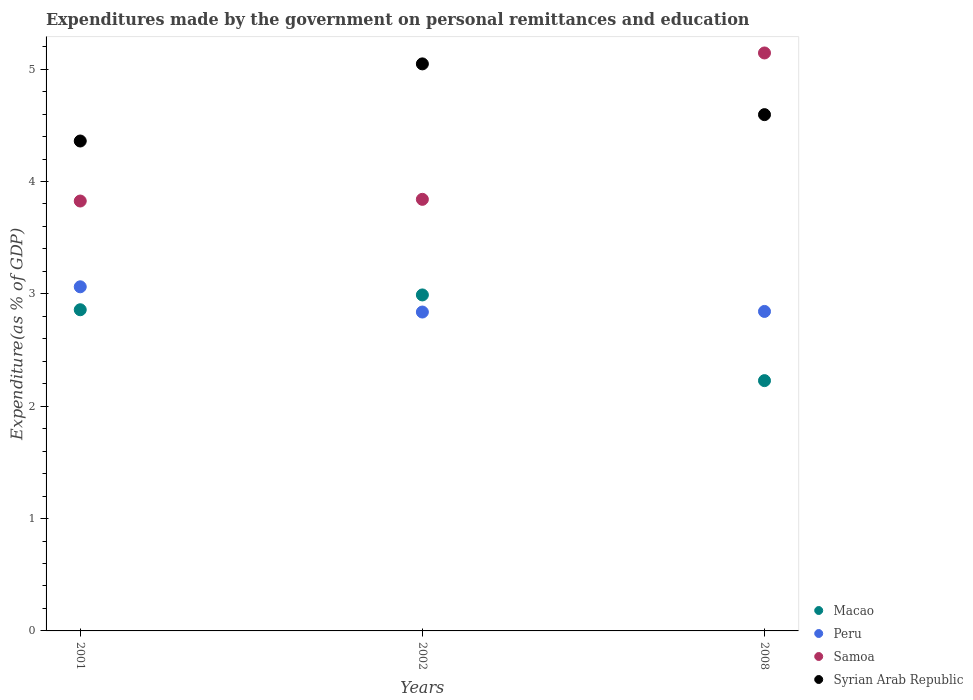What is the expenditures made by the government on personal remittances and education in Peru in 2008?
Your response must be concise. 2.84. Across all years, what is the maximum expenditures made by the government on personal remittances and education in Syrian Arab Republic?
Provide a succinct answer. 5.05. Across all years, what is the minimum expenditures made by the government on personal remittances and education in Samoa?
Provide a short and direct response. 3.83. What is the total expenditures made by the government on personal remittances and education in Samoa in the graph?
Provide a short and direct response. 12.81. What is the difference between the expenditures made by the government on personal remittances and education in Syrian Arab Republic in 2001 and that in 2008?
Ensure brevity in your answer.  -0.23. What is the difference between the expenditures made by the government on personal remittances and education in Samoa in 2001 and the expenditures made by the government on personal remittances and education in Macao in 2008?
Ensure brevity in your answer.  1.6. What is the average expenditures made by the government on personal remittances and education in Macao per year?
Offer a very short reply. 2.69. In the year 2001, what is the difference between the expenditures made by the government on personal remittances and education in Samoa and expenditures made by the government on personal remittances and education in Peru?
Offer a terse response. 0.76. In how many years, is the expenditures made by the government on personal remittances and education in Syrian Arab Republic greater than 0.4 %?
Keep it short and to the point. 3. What is the ratio of the expenditures made by the government on personal remittances and education in Samoa in 2001 to that in 2008?
Your answer should be compact. 0.74. Is the expenditures made by the government on personal remittances and education in Macao in 2001 less than that in 2008?
Your response must be concise. No. Is the difference between the expenditures made by the government on personal remittances and education in Samoa in 2001 and 2008 greater than the difference between the expenditures made by the government on personal remittances and education in Peru in 2001 and 2008?
Provide a succinct answer. No. What is the difference between the highest and the second highest expenditures made by the government on personal remittances and education in Macao?
Your answer should be compact. 0.13. What is the difference between the highest and the lowest expenditures made by the government on personal remittances and education in Syrian Arab Republic?
Your answer should be compact. 0.69. In how many years, is the expenditures made by the government on personal remittances and education in Samoa greater than the average expenditures made by the government on personal remittances and education in Samoa taken over all years?
Provide a short and direct response. 1. Is the sum of the expenditures made by the government on personal remittances and education in Syrian Arab Republic in 2002 and 2008 greater than the maximum expenditures made by the government on personal remittances and education in Peru across all years?
Provide a succinct answer. Yes. Is it the case that in every year, the sum of the expenditures made by the government on personal remittances and education in Samoa and expenditures made by the government on personal remittances and education in Syrian Arab Republic  is greater than the sum of expenditures made by the government on personal remittances and education in Peru and expenditures made by the government on personal remittances and education in Macao?
Offer a very short reply. Yes. Is the expenditures made by the government on personal remittances and education in Macao strictly greater than the expenditures made by the government on personal remittances and education in Samoa over the years?
Your answer should be compact. No. Is the expenditures made by the government on personal remittances and education in Samoa strictly less than the expenditures made by the government on personal remittances and education in Syrian Arab Republic over the years?
Ensure brevity in your answer.  No. What is the difference between two consecutive major ticks on the Y-axis?
Give a very brief answer. 1. Are the values on the major ticks of Y-axis written in scientific E-notation?
Your answer should be very brief. No. Does the graph contain any zero values?
Ensure brevity in your answer.  No. How many legend labels are there?
Give a very brief answer. 4. What is the title of the graph?
Your answer should be very brief. Expenditures made by the government on personal remittances and education. What is the label or title of the X-axis?
Offer a terse response. Years. What is the label or title of the Y-axis?
Ensure brevity in your answer.  Expenditure(as % of GDP). What is the Expenditure(as % of GDP) in Macao in 2001?
Provide a short and direct response. 2.86. What is the Expenditure(as % of GDP) of Peru in 2001?
Ensure brevity in your answer.  3.06. What is the Expenditure(as % of GDP) in Samoa in 2001?
Your answer should be compact. 3.83. What is the Expenditure(as % of GDP) of Syrian Arab Republic in 2001?
Your answer should be compact. 4.36. What is the Expenditure(as % of GDP) in Macao in 2002?
Your answer should be very brief. 2.99. What is the Expenditure(as % of GDP) of Peru in 2002?
Keep it short and to the point. 2.84. What is the Expenditure(as % of GDP) in Samoa in 2002?
Give a very brief answer. 3.84. What is the Expenditure(as % of GDP) in Syrian Arab Republic in 2002?
Ensure brevity in your answer.  5.05. What is the Expenditure(as % of GDP) in Macao in 2008?
Your response must be concise. 2.23. What is the Expenditure(as % of GDP) of Peru in 2008?
Your answer should be compact. 2.84. What is the Expenditure(as % of GDP) in Samoa in 2008?
Ensure brevity in your answer.  5.14. What is the Expenditure(as % of GDP) in Syrian Arab Republic in 2008?
Make the answer very short. 4.6. Across all years, what is the maximum Expenditure(as % of GDP) of Macao?
Ensure brevity in your answer.  2.99. Across all years, what is the maximum Expenditure(as % of GDP) of Peru?
Give a very brief answer. 3.06. Across all years, what is the maximum Expenditure(as % of GDP) in Samoa?
Your answer should be compact. 5.14. Across all years, what is the maximum Expenditure(as % of GDP) of Syrian Arab Republic?
Your answer should be very brief. 5.05. Across all years, what is the minimum Expenditure(as % of GDP) of Macao?
Ensure brevity in your answer.  2.23. Across all years, what is the minimum Expenditure(as % of GDP) in Peru?
Keep it short and to the point. 2.84. Across all years, what is the minimum Expenditure(as % of GDP) of Samoa?
Provide a succinct answer. 3.83. Across all years, what is the minimum Expenditure(as % of GDP) in Syrian Arab Republic?
Give a very brief answer. 4.36. What is the total Expenditure(as % of GDP) in Macao in the graph?
Provide a short and direct response. 8.08. What is the total Expenditure(as % of GDP) of Peru in the graph?
Provide a short and direct response. 8.74. What is the total Expenditure(as % of GDP) in Samoa in the graph?
Provide a succinct answer. 12.81. What is the total Expenditure(as % of GDP) of Syrian Arab Republic in the graph?
Keep it short and to the point. 14. What is the difference between the Expenditure(as % of GDP) in Macao in 2001 and that in 2002?
Make the answer very short. -0.13. What is the difference between the Expenditure(as % of GDP) of Peru in 2001 and that in 2002?
Offer a terse response. 0.22. What is the difference between the Expenditure(as % of GDP) of Samoa in 2001 and that in 2002?
Offer a terse response. -0.02. What is the difference between the Expenditure(as % of GDP) in Syrian Arab Republic in 2001 and that in 2002?
Keep it short and to the point. -0.69. What is the difference between the Expenditure(as % of GDP) of Macao in 2001 and that in 2008?
Ensure brevity in your answer.  0.63. What is the difference between the Expenditure(as % of GDP) in Peru in 2001 and that in 2008?
Your response must be concise. 0.22. What is the difference between the Expenditure(as % of GDP) of Samoa in 2001 and that in 2008?
Your response must be concise. -1.32. What is the difference between the Expenditure(as % of GDP) in Syrian Arab Republic in 2001 and that in 2008?
Offer a very short reply. -0.23. What is the difference between the Expenditure(as % of GDP) in Macao in 2002 and that in 2008?
Your answer should be very brief. 0.76. What is the difference between the Expenditure(as % of GDP) of Peru in 2002 and that in 2008?
Give a very brief answer. -0.01. What is the difference between the Expenditure(as % of GDP) of Samoa in 2002 and that in 2008?
Give a very brief answer. -1.3. What is the difference between the Expenditure(as % of GDP) in Syrian Arab Republic in 2002 and that in 2008?
Make the answer very short. 0.45. What is the difference between the Expenditure(as % of GDP) of Macao in 2001 and the Expenditure(as % of GDP) of Peru in 2002?
Your answer should be compact. 0.02. What is the difference between the Expenditure(as % of GDP) of Macao in 2001 and the Expenditure(as % of GDP) of Samoa in 2002?
Give a very brief answer. -0.98. What is the difference between the Expenditure(as % of GDP) in Macao in 2001 and the Expenditure(as % of GDP) in Syrian Arab Republic in 2002?
Your answer should be very brief. -2.19. What is the difference between the Expenditure(as % of GDP) in Peru in 2001 and the Expenditure(as % of GDP) in Samoa in 2002?
Your answer should be compact. -0.78. What is the difference between the Expenditure(as % of GDP) of Peru in 2001 and the Expenditure(as % of GDP) of Syrian Arab Republic in 2002?
Ensure brevity in your answer.  -1.98. What is the difference between the Expenditure(as % of GDP) of Samoa in 2001 and the Expenditure(as % of GDP) of Syrian Arab Republic in 2002?
Your answer should be compact. -1.22. What is the difference between the Expenditure(as % of GDP) of Macao in 2001 and the Expenditure(as % of GDP) of Peru in 2008?
Ensure brevity in your answer.  0.01. What is the difference between the Expenditure(as % of GDP) in Macao in 2001 and the Expenditure(as % of GDP) in Samoa in 2008?
Your answer should be compact. -2.29. What is the difference between the Expenditure(as % of GDP) in Macao in 2001 and the Expenditure(as % of GDP) in Syrian Arab Republic in 2008?
Make the answer very short. -1.74. What is the difference between the Expenditure(as % of GDP) of Peru in 2001 and the Expenditure(as % of GDP) of Samoa in 2008?
Give a very brief answer. -2.08. What is the difference between the Expenditure(as % of GDP) in Peru in 2001 and the Expenditure(as % of GDP) in Syrian Arab Republic in 2008?
Give a very brief answer. -1.53. What is the difference between the Expenditure(as % of GDP) of Samoa in 2001 and the Expenditure(as % of GDP) of Syrian Arab Republic in 2008?
Make the answer very short. -0.77. What is the difference between the Expenditure(as % of GDP) in Macao in 2002 and the Expenditure(as % of GDP) in Peru in 2008?
Offer a terse response. 0.15. What is the difference between the Expenditure(as % of GDP) of Macao in 2002 and the Expenditure(as % of GDP) of Samoa in 2008?
Make the answer very short. -2.15. What is the difference between the Expenditure(as % of GDP) in Macao in 2002 and the Expenditure(as % of GDP) in Syrian Arab Republic in 2008?
Offer a very short reply. -1.6. What is the difference between the Expenditure(as % of GDP) in Peru in 2002 and the Expenditure(as % of GDP) in Samoa in 2008?
Keep it short and to the point. -2.31. What is the difference between the Expenditure(as % of GDP) in Peru in 2002 and the Expenditure(as % of GDP) in Syrian Arab Republic in 2008?
Give a very brief answer. -1.76. What is the difference between the Expenditure(as % of GDP) of Samoa in 2002 and the Expenditure(as % of GDP) of Syrian Arab Republic in 2008?
Offer a very short reply. -0.75. What is the average Expenditure(as % of GDP) in Macao per year?
Provide a succinct answer. 2.69. What is the average Expenditure(as % of GDP) of Peru per year?
Offer a terse response. 2.91. What is the average Expenditure(as % of GDP) of Samoa per year?
Ensure brevity in your answer.  4.27. What is the average Expenditure(as % of GDP) in Syrian Arab Republic per year?
Your answer should be very brief. 4.67. In the year 2001, what is the difference between the Expenditure(as % of GDP) in Macao and Expenditure(as % of GDP) in Peru?
Provide a succinct answer. -0.2. In the year 2001, what is the difference between the Expenditure(as % of GDP) of Macao and Expenditure(as % of GDP) of Samoa?
Your answer should be very brief. -0.97. In the year 2001, what is the difference between the Expenditure(as % of GDP) of Macao and Expenditure(as % of GDP) of Syrian Arab Republic?
Your answer should be compact. -1.5. In the year 2001, what is the difference between the Expenditure(as % of GDP) of Peru and Expenditure(as % of GDP) of Samoa?
Keep it short and to the point. -0.76. In the year 2001, what is the difference between the Expenditure(as % of GDP) of Peru and Expenditure(as % of GDP) of Syrian Arab Republic?
Offer a very short reply. -1.3. In the year 2001, what is the difference between the Expenditure(as % of GDP) of Samoa and Expenditure(as % of GDP) of Syrian Arab Republic?
Keep it short and to the point. -0.53. In the year 2002, what is the difference between the Expenditure(as % of GDP) of Macao and Expenditure(as % of GDP) of Peru?
Your answer should be compact. 0.15. In the year 2002, what is the difference between the Expenditure(as % of GDP) in Macao and Expenditure(as % of GDP) in Samoa?
Provide a succinct answer. -0.85. In the year 2002, what is the difference between the Expenditure(as % of GDP) of Macao and Expenditure(as % of GDP) of Syrian Arab Republic?
Keep it short and to the point. -2.06. In the year 2002, what is the difference between the Expenditure(as % of GDP) in Peru and Expenditure(as % of GDP) in Samoa?
Offer a very short reply. -1. In the year 2002, what is the difference between the Expenditure(as % of GDP) of Peru and Expenditure(as % of GDP) of Syrian Arab Republic?
Your answer should be compact. -2.21. In the year 2002, what is the difference between the Expenditure(as % of GDP) of Samoa and Expenditure(as % of GDP) of Syrian Arab Republic?
Your answer should be very brief. -1.21. In the year 2008, what is the difference between the Expenditure(as % of GDP) of Macao and Expenditure(as % of GDP) of Peru?
Your response must be concise. -0.62. In the year 2008, what is the difference between the Expenditure(as % of GDP) in Macao and Expenditure(as % of GDP) in Samoa?
Ensure brevity in your answer.  -2.92. In the year 2008, what is the difference between the Expenditure(as % of GDP) of Macao and Expenditure(as % of GDP) of Syrian Arab Republic?
Ensure brevity in your answer.  -2.37. In the year 2008, what is the difference between the Expenditure(as % of GDP) of Peru and Expenditure(as % of GDP) of Samoa?
Your response must be concise. -2.3. In the year 2008, what is the difference between the Expenditure(as % of GDP) in Peru and Expenditure(as % of GDP) in Syrian Arab Republic?
Ensure brevity in your answer.  -1.75. In the year 2008, what is the difference between the Expenditure(as % of GDP) of Samoa and Expenditure(as % of GDP) of Syrian Arab Republic?
Ensure brevity in your answer.  0.55. What is the ratio of the Expenditure(as % of GDP) of Macao in 2001 to that in 2002?
Provide a succinct answer. 0.96. What is the ratio of the Expenditure(as % of GDP) in Peru in 2001 to that in 2002?
Your answer should be compact. 1.08. What is the ratio of the Expenditure(as % of GDP) in Syrian Arab Republic in 2001 to that in 2002?
Ensure brevity in your answer.  0.86. What is the ratio of the Expenditure(as % of GDP) in Macao in 2001 to that in 2008?
Ensure brevity in your answer.  1.28. What is the ratio of the Expenditure(as % of GDP) in Peru in 2001 to that in 2008?
Your answer should be compact. 1.08. What is the ratio of the Expenditure(as % of GDP) of Samoa in 2001 to that in 2008?
Your response must be concise. 0.74. What is the ratio of the Expenditure(as % of GDP) in Syrian Arab Republic in 2001 to that in 2008?
Your response must be concise. 0.95. What is the ratio of the Expenditure(as % of GDP) in Macao in 2002 to that in 2008?
Your answer should be very brief. 1.34. What is the ratio of the Expenditure(as % of GDP) in Peru in 2002 to that in 2008?
Keep it short and to the point. 1. What is the ratio of the Expenditure(as % of GDP) in Samoa in 2002 to that in 2008?
Ensure brevity in your answer.  0.75. What is the ratio of the Expenditure(as % of GDP) of Syrian Arab Republic in 2002 to that in 2008?
Give a very brief answer. 1.1. What is the difference between the highest and the second highest Expenditure(as % of GDP) of Macao?
Keep it short and to the point. 0.13. What is the difference between the highest and the second highest Expenditure(as % of GDP) in Peru?
Offer a terse response. 0.22. What is the difference between the highest and the second highest Expenditure(as % of GDP) in Samoa?
Ensure brevity in your answer.  1.3. What is the difference between the highest and the second highest Expenditure(as % of GDP) of Syrian Arab Republic?
Provide a short and direct response. 0.45. What is the difference between the highest and the lowest Expenditure(as % of GDP) in Macao?
Your answer should be compact. 0.76. What is the difference between the highest and the lowest Expenditure(as % of GDP) of Peru?
Give a very brief answer. 0.22. What is the difference between the highest and the lowest Expenditure(as % of GDP) in Samoa?
Keep it short and to the point. 1.32. What is the difference between the highest and the lowest Expenditure(as % of GDP) in Syrian Arab Republic?
Your response must be concise. 0.69. 